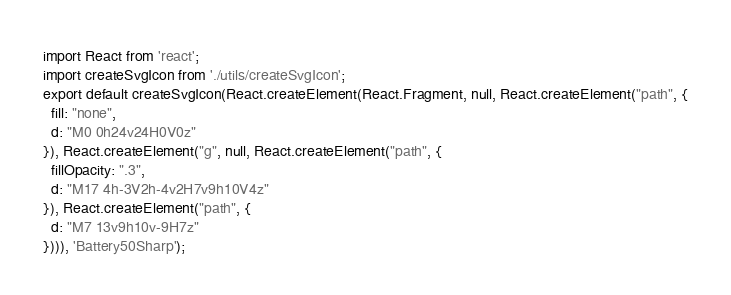Convert code to text. <code><loc_0><loc_0><loc_500><loc_500><_JavaScript_>import React from 'react';
import createSvgIcon from './utils/createSvgIcon';
export default createSvgIcon(React.createElement(React.Fragment, null, React.createElement("path", {
  fill: "none",
  d: "M0 0h24v24H0V0z"
}), React.createElement("g", null, React.createElement("path", {
  fillOpacity: ".3",
  d: "M17 4h-3V2h-4v2H7v9h10V4z"
}), React.createElement("path", {
  d: "M7 13v9h10v-9H7z"
}))), 'Battery50Sharp');</code> 